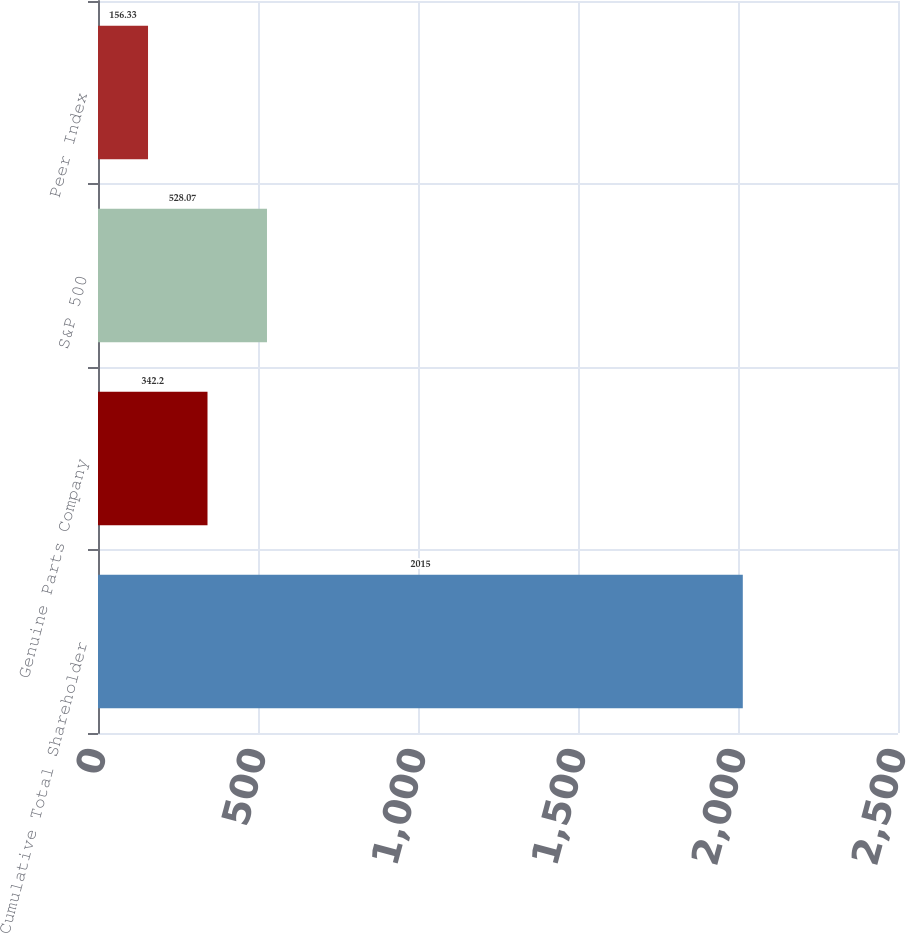Convert chart. <chart><loc_0><loc_0><loc_500><loc_500><bar_chart><fcel>Cumulative Total Shareholder<fcel>Genuine Parts Company<fcel>S&P 500<fcel>Peer Index<nl><fcel>2015<fcel>342.2<fcel>528.07<fcel>156.33<nl></chart> 